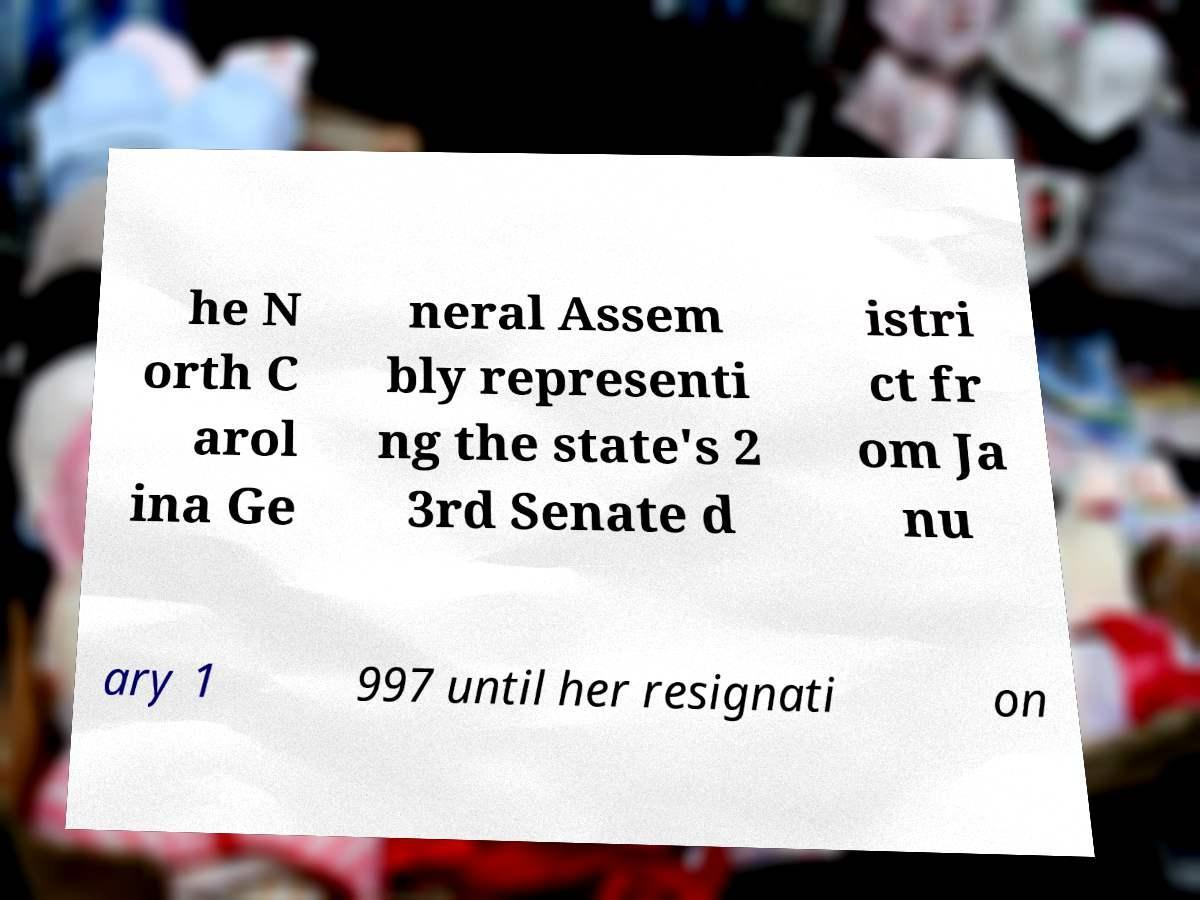For documentation purposes, I need the text within this image transcribed. Could you provide that? he N orth C arol ina Ge neral Assem bly representi ng the state's 2 3rd Senate d istri ct fr om Ja nu ary 1 997 until her resignati on 